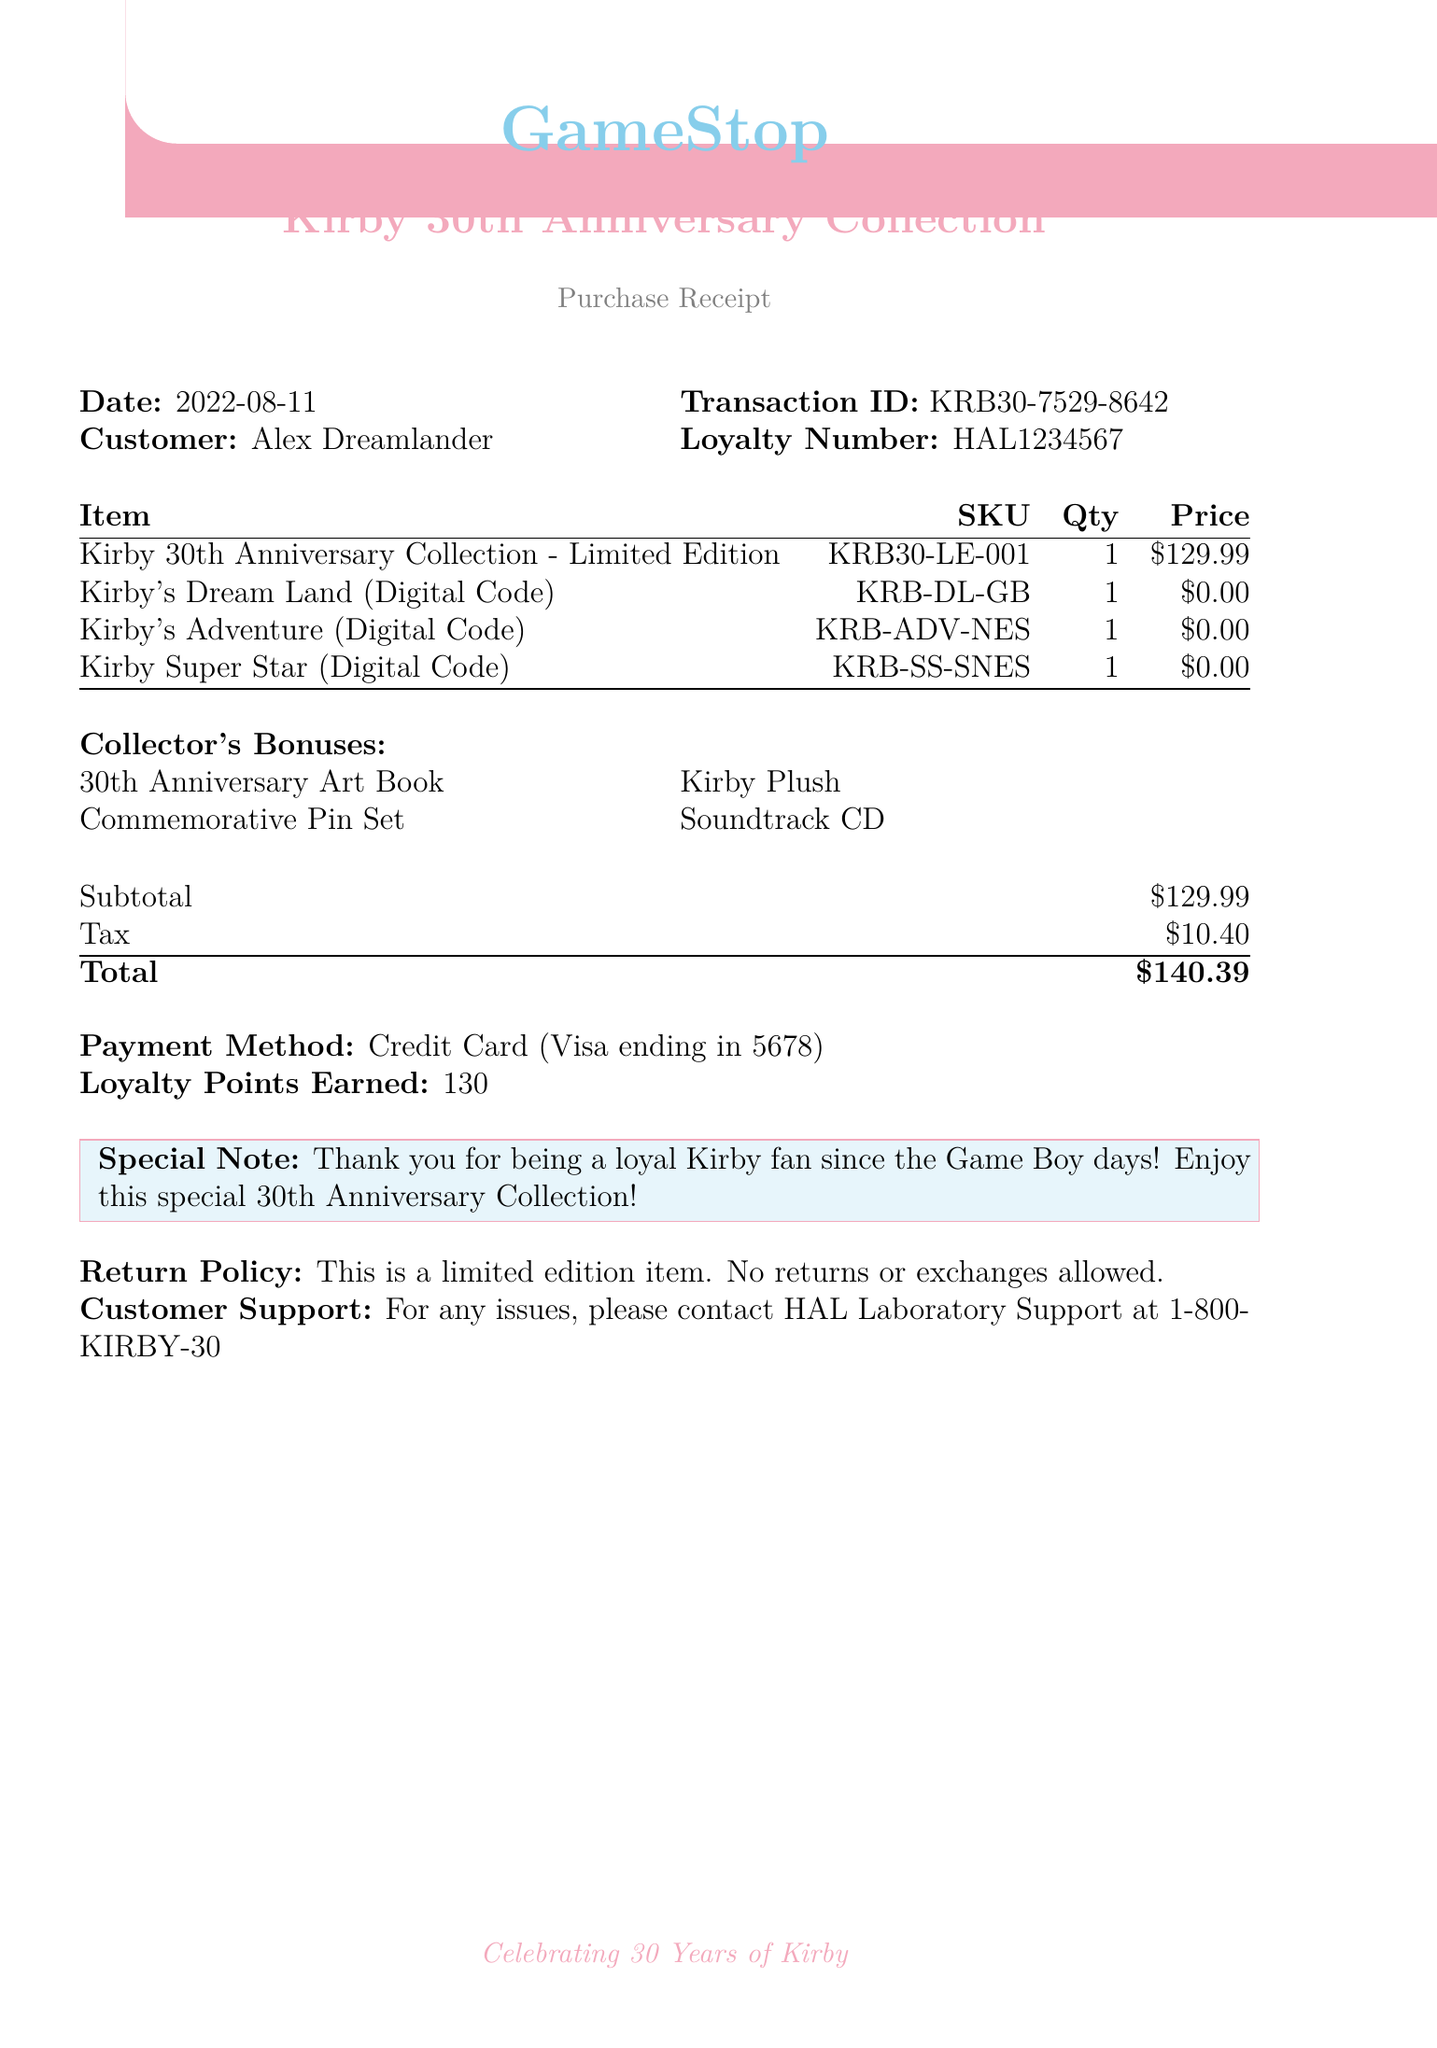What is the store name? The store name is listed at the top of the document, which is GameStop.
Answer: GameStop What was the purchase date? The purchase date is provided in the document under the date section, which is 2022-08-11.
Answer: 2022-08-11 Who is the customer? The customer's name is found near the top of the document, listed as Alex Dreamlander.
Answer: Alex Dreamlander What is the subtotal amount? The subtotal amount is mentioned in the financial summary section, which is $129.99.
Answer: $129.99 How many loyalty points were earned? The number of loyalty points earned is specified in the document, which is 130.
Answer: 130 What item was purchased in limited edition? The document lists the item purchased in limited edition, which is the Kirby 30th Anniversary Collection - Limited Edition.
Answer: Kirby 30th Anniversary Collection - Limited Edition What is the return policy for this purchase? The return policy is described in the document, stating that no returns or exchanges are allowed.
Answer: No returns or exchanges allowed What is included in the collector's bonuses? The collector's bonuses section lists multiple items; the first one mentioned is the 30th Anniversary Art Book.
Answer: 30th Anniversary Art Book What payment method was used? The payment method is indicated in the document, which states Credit Card (Visa ending in 5678).
Answer: Credit Card (Visa ending in 5678) 